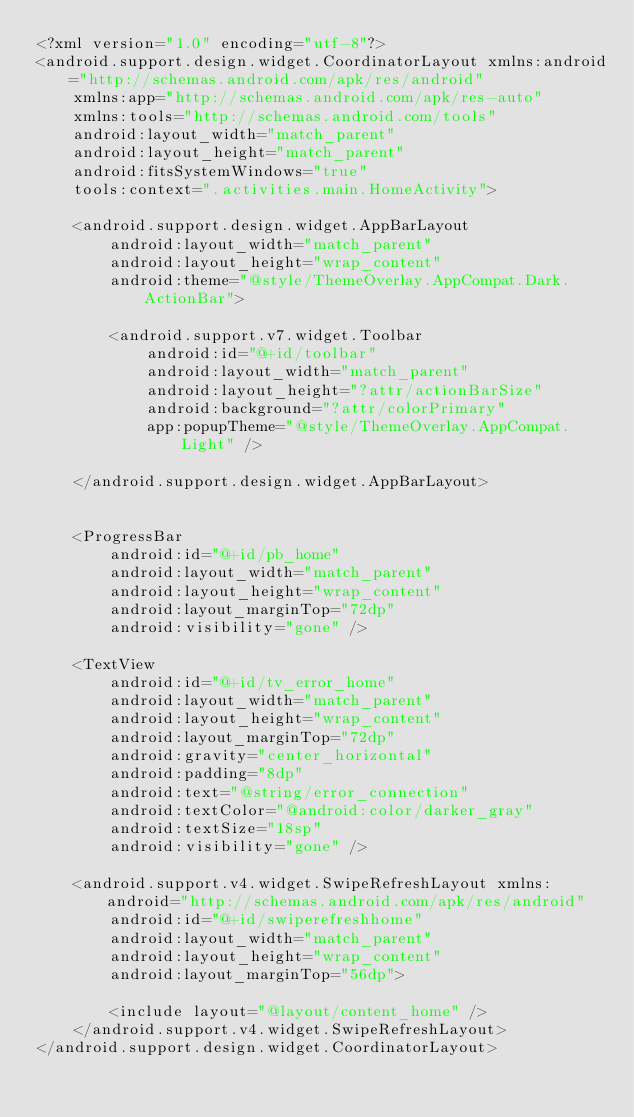Convert code to text. <code><loc_0><loc_0><loc_500><loc_500><_XML_><?xml version="1.0" encoding="utf-8"?>
<android.support.design.widget.CoordinatorLayout xmlns:android="http://schemas.android.com/apk/res/android"
    xmlns:app="http://schemas.android.com/apk/res-auto"
    xmlns:tools="http://schemas.android.com/tools"
    android:layout_width="match_parent"
    android:layout_height="match_parent"
    android:fitsSystemWindows="true"
    tools:context=".activities.main.HomeActivity">

    <android.support.design.widget.AppBarLayout
        android:layout_width="match_parent"
        android:layout_height="wrap_content"
        android:theme="@style/ThemeOverlay.AppCompat.Dark.ActionBar">

        <android.support.v7.widget.Toolbar
            android:id="@+id/toolbar"
            android:layout_width="match_parent"
            android:layout_height="?attr/actionBarSize"
            android:background="?attr/colorPrimary"
            app:popupTheme="@style/ThemeOverlay.AppCompat.Light" />

    </android.support.design.widget.AppBarLayout>


    <ProgressBar
        android:id="@+id/pb_home"
        android:layout_width="match_parent"
        android:layout_height="wrap_content"
        android:layout_marginTop="72dp"
        android:visibility="gone" />

    <TextView
        android:id="@+id/tv_error_home"
        android:layout_width="match_parent"
        android:layout_height="wrap_content"
        android:layout_marginTop="72dp"
        android:gravity="center_horizontal"
        android:padding="8dp"
        android:text="@string/error_connection"
        android:textColor="@android:color/darker_gray"
        android:textSize="18sp"
        android:visibility="gone" />

    <android.support.v4.widget.SwipeRefreshLayout xmlns:android="http://schemas.android.com/apk/res/android"
        android:id="@+id/swiperefreshhome"
        android:layout_width="match_parent"
        android:layout_height="wrap_content"
        android:layout_marginTop="56dp">

        <include layout="@layout/content_home" />
    </android.support.v4.widget.SwipeRefreshLayout>
</android.support.design.widget.CoordinatorLayout>
</code> 